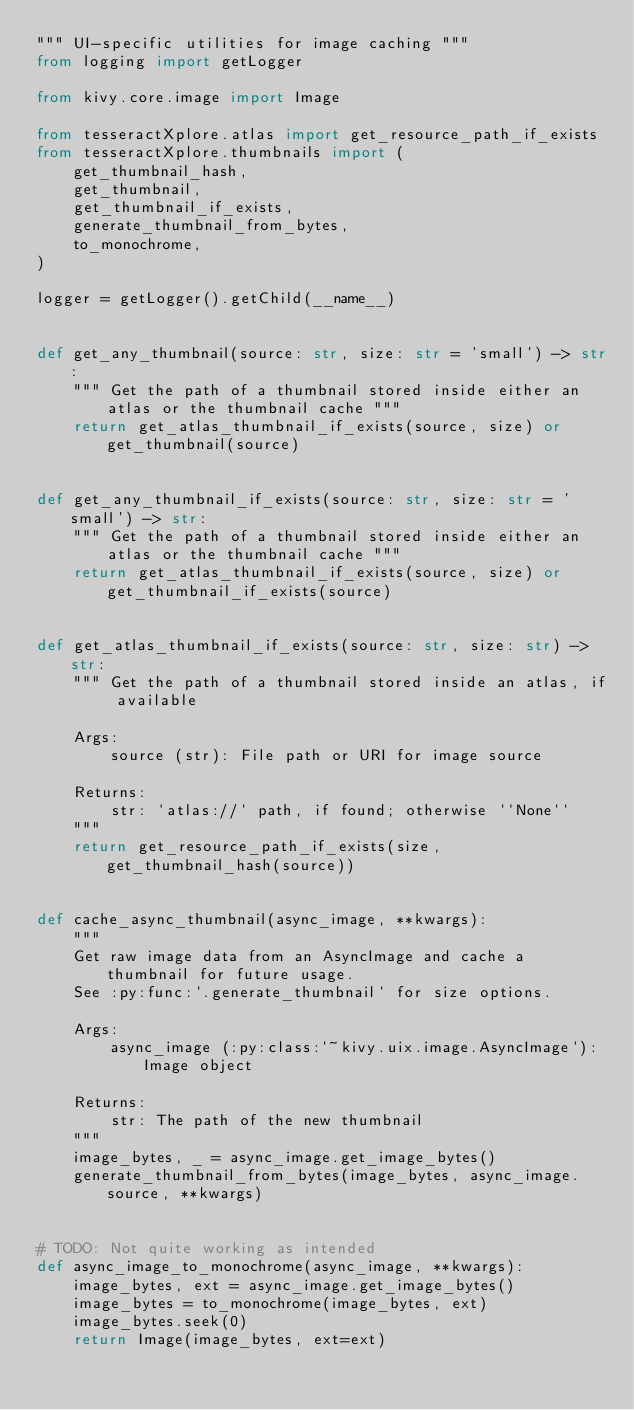Convert code to text. <code><loc_0><loc_0><loc_500><loc_500><_Python_>""" UI-specific utilities for image caching """
from logging import getLogger

from kivy.core.image import Image

from tesseractXplore.atlas import get_resource_path_if_exists
from tesseractXplore.thumbnails import (
    get_thumbnail_hash,
    get_thumbnail,
    get_thumbnail_if_exists,
    generate_thumbnail_from_bytes,
    to_monochrome,
)

logger = getLogger().getChild(__name__)


def get_any_thumbnail(source: str, size: str = 'small') -> str:
    """ Get the path of a thumbnail stored inside either an atlas or the thumbnail cache """
    return get_atlas_thumbnail_if_exists(source, size) or get_thumbnail(source)


def get_any_thumbnail_if_exists(source: str, size: str = 'small') -> str:
    """ Get the path of a thumbnail stored inside either an atlas or the thumbnail cache """
    return get_atlas_thumbnail_if_exists(source, size) or get_thumbnail_if_exists(source)


def get_atlas_thumbnail_if_exists(source: str, size: str) -> str:
    """ Get the path of a thumbnail stored inside an atlas, if available

    Args:
        source (str): File path or URI for image source

    Returns:
        str: `atlas://` path, if found; otherwise ``None``
    """
    return get_resource_path_if_exists(size, get_thumbnail_hash(source))


def cache_async_thumbnail(async_image, **kwargs):
    """
    Get raw image data from an AsyncImage and cache a thumbnail for future usage.
    See :py:func:`.generate_thumbnail` for size options.

    Args:
        async_image (:py:class:`~kivy.uix.image.AsyncImage`): Image object

    Returns:
        str: The path of the new thumbnail
    """
    image_bytes, _ = async_image.get_image_bytes()
    generate_thumbnail_from_bytes(image_bytes, async_image.source, **kwargs)


# TODO: Not quite working as intended
def async_image_to_monochrome(async_image, **kwargs):
    image_bytes, ext = async_image.get_image_bytes()
    image_bytes = to_monochrome(image_bytes, ext)
    image_bytes.seek(0)
    return Image(image_bytes, ext=ext)
</code> 